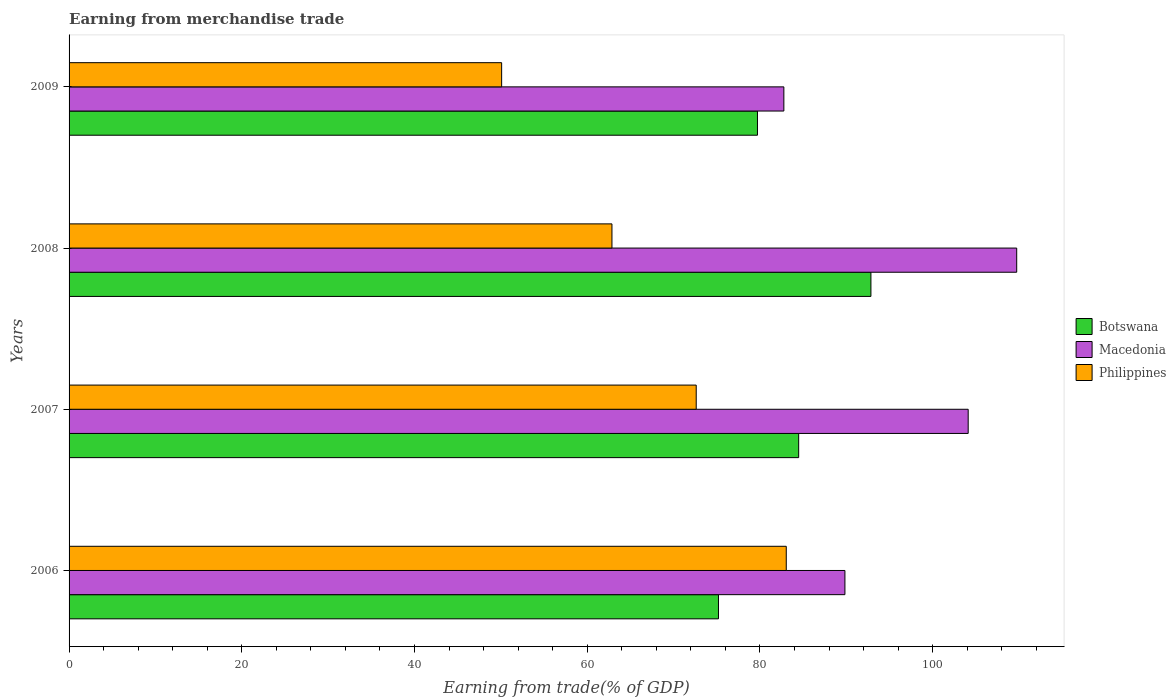How many different coloured bars are there?
Offer a very short reply. 3. How many groups of bars are there?
Give a very brief answer. 4. Are the number of bars per tick equal to the number of legend labels?
Provide a succinct answer. Yes. In how many cases, is the number of bars for a given year not equal to the number of legend labels?
Keep it short and to the point. 0. What is the earnings from trade in Philippines in 2006?
Ensure brevity in your answer.  83.04. Across all years, what is the maximum earnings from trade in Macedonia?
Offer a terse response. 109.73. Across all years, what is the minimum earnings from trade in Philippines?
Offer a very short reply. 50.09. In which year was the earnings from trade in Botswana minimum?
Give a very brief answer. 2006. What is the total earnings from trade in Botswana in the graph?
Provide a short and direct response. 332.23. What is the difference between the earnings from trade in Macedonia in 2006 and that in 2007?
Make the answer very short. -14.27. What is the difference between the earnings from trade in Botswana in 2006 and the earnings from trade in Philippines in 2009?
Your answer should be very brief. 25.11. What is the average earnings from trade in Philippines per year?
Provide a succinct answer. 67.15. In the year 2007, what is the difference between the earnings from trade in Botswana and earnings from trade in Macedonia?
Give a very brief answer. -19.63. In how many years, is the earnings from trade in Botswana greater than 68 %?
Make the answer very short. 4. What is the ratio of the earnings from trade in Botswana in 2007 to that in 2008?
Make the answer very short. 0.91. What is the difference between the highest and the second highest earnings from trade in Botswana?
Keep it short and to the point. 8.37. What is the difference between the highest and the lowest earnings from trade in Philippines?
Offer a very short reply. 32.96. In how many years, is the earnings from trade in Philippines greater than the average earnings from trade in Philippines taken over all years?
Keep it short and to the point. 2. What does the 3rd bar from the top in 2008 represents?
Provide a succinct answer. Botswana. What does the 2nd bar from the bottom in 2008 represents?
Give a very brief answer. Macedonia. How many bars are there?
Ensure brevity in your answer.  12. Are all the bars in the graph horizontal?
Offer a very short reply. Yes. Are the values on the major ticks of X-axis written in scientific E-notation?
Your answer should be compact. No. Where does the legend appear in the graph?
Ensure brevity in your answer.  Center right. What is the title of the graph?
Your response must be concise. Earning from merchandise trade. Does "Hungary" appear as one of the legend labels in the graph?
Your response must be concise. No. What is the label or title of the X-axis?
Give a very brief answer. Earning from trade(% of GDP). What is the Earning from trade(% of GDP) in Botswana in 2006?
Offer a terse response. 75.19. What is the Earning from trade(% of GDP) of Macedonia in 2006?
Give a very brief answer. 89.83. What is the Earning from trade(% of GDP) in Philippines in 2006?
Your answer should be compact. 83.04. What is the Earning from trade(% of GDP) in Botswana in 2007?
Offer a very short reply. 84.48. What is the Earning from trade(% of GDP) of Macedonia in 2007?
Give a very brief answer. 104.11. What is the Earning from trade(% of GDP) in Philippines in 2007?
Make the answer very short. 72.62. What is the Earning from trade(% of GDP) of Botswana in 2008?
Your answer should be very brief. 92.85. What is the Earning from trade(% of GDP) in Macedonia in 2008?
Offer a very short reply. 109.73. What is the Earning from trade(% of GDP) of Philippines in 2008?
Ensure brevity in your answer.  62.86. What is the Earning from trade(% of GDP) of Botswana in 2009?
Your answer should be very brief. 79.71. What is the Earning from trade(% of GDP) of Macedonia in 2009?
Give a very brief answer. 82.76. What is the Earning from trade(% of GDP) in Philippines in 2009?
Provide a succinct answer. 50.09. Across all years, what is the maximum Earning from trade(% of GDP) of Botswana?
Give a very brief answer. 92.85. Across all years, what is the maximum Earning from trade(% of GDP) of Macedonia?
Give a very brief answer. 109.73. Across all years, what is the maximum Earning from trade(% of GDP) of Philippines?
Offer a terse response. 83.04. Across all years, what is the minimum Earning from trade(% of GDP) in Botswana?
Offer a terse response. 75.19. Across all years, what is the minimum Earning from trade(% of GDP) of Macedonia?
Your answer should be very brief. 82.76. Across all years, what is the minimum Earning from trade(% of GDP) of Philippines?
Make the answer very short. 50.09. What is the total Earning from trade(% of GDP) in Botswana in the graph?
Offer a very short reply. 332.23. What is the total Earning from trade(% of GDP) of Macedonia in the graph?
Offer a terse response. 386.43. What is the total Earning from trade(% of GDP) of Philippines in the graph?
Give a very brief answer. 268.61. What is the difference between the Earning from trade(% of GDP) of Botswana in 2006 and that in 2007?
Your answer should be compact. -9.29. What is the difference between the Earning from trade(% of GDP) of Macedonia in 2006 and that in 2007?
Your response must be concise. -14.27. What is the difference between the Earning from trade(% of GDP) in Philippines in 2006 and that in 2007?
Ensure brevity in your answer.  10.43. What is the difference between the Earning from trade(% of GDP) of Botswana in 2006 and that in 2008?
Offer a very short reply. -17.65. What is the difference between the Earning from trade(% of GDP) in Macedonia in 2006 and that in 2008?
Ensure brevity in your answer.  -19.89. What is the difference between the Earning from trade(% of GDP) of Philippines in 2006 and that in 2008?
Make the answer very short. 20.18. What is the difference between the Earning from trade(% of GDP) of Botswana in 2006 and that in 2009?
Provide a short and direct response. -4.51. What is the difference between the Earning from trade(% of GDP) in Macedonia in 2006 and that in 2009?
Give a very brief answer. 7.07. What is the difference between the Earning from trade(% of GDP) in Philippines in 2006 and that in 2009?
Provide a short and direct response. 32.96. What is the difference between the Earning from trade(% of GDP) in Botswana in 2007 and that in 2008?
Provide a short and direct response. -8.37. What is the difference between the Earning from trade(% of GDP) in Macedonia in 2007 and that in 2008?
Keep it short and to the point. -5.62. What is the difference between the Earning from trade(% of GDP) of Philippines in 2007 and that in 2008?
Offer a terse response. 9.76. What is the difference between the Earning from trade(% of GDP) in Botswana in 2007 and that in 2009?
Your answer should be very brief. 4.77. What is the difference between the Earning from trade(% of GDP) in Macedonia in 2007 and that in 2009?
Your response must be concise. 21.34. What is the difference between the Earning from trade(% of GDP) of Philippines in 2007 and that in 2009?
Provide a short and direct response. 22.53. What is the difference between the Earning from trade(% of GDP) in Botswana in 2008 and that in 2009?
Your response must be concise. 13.14. What is the difference between the Earning from trade(% of GDP) in Macedonia in 2008 and that in 2009?
Your response must be concise. 26.96. What is the difference between the Earning from trade(% of GDP) in Philippines in 2008 and that in 2009?
Make the answer very short. 12.77. What is the difference between the Earning from trade(% of GDP) of Botswana in 2006 and the Earning from trade(% of GDP) of Macedonia in 2007?
Offer a terse response. -28.91. What is the difference between the Earning from trade(% of GDP) in Botswana in 2006 and the Earning from trade(% of GDP) in Philippines in 2007?
Make the answer very short. 2.58. What is the difference between the Earning from trade(% of GDP) of Macedonia in 2006 and the Earning from trade(% of GDP) of Philippines in 2007?
Your response must be concise. 17.22. What is the difference between the Earning from trade(% of GDP) in Botswana in 2006 and the Earning from trade(% of GDP) in Macedonia in 2008?
Provide a short and direct response. -34.53. What is the difference between the Earning from trade(% of GDP) of Botswana in 2006 and the Earning from trade(% of GDP) of Philippines in 2008?
Make the answer very short. 12.33. What is the difference between the Earning from trade(% of GDP) in Macedonia in 2006 and the Earning from trade(% of GDP) in Philippines in 2008?
Provide a succinct answer. 26.98. What is the difference between the Earning from trade(% of GDP) of Botswana in 2006 and the Earning from trade(% of GDP) of Macedonia in 2009?
Provide a short and direct response. -7.57. What is the difference between the Earning from trade(% of GDP) of Botswana in 2006 and the Earning from trade(% of GDP) of Philippines in 2009?
Provide a short and direct response. 25.11. What is the difference between the Earning from trade(% of GDP) of Macedonia in 2006 and the Earning from trade(% of GDP) of Philippines in 2009?
Give a very brief answer. 39.75. What is the difference between the Earning from trade(% of GDP) of Botswana in 2007 and the Earning from trade(% of GDP) of Macedonia in 2008?
Provide a succinct answer. -25.25. What is the difference between the Earning from trade(% of GDP) in Botswana in 2007 and the Earning from trade(% of GDP) in Philippines in 2008?
Provide a short and direct response. 21.62. What is the difference between the Earning from trade(% of GDP) in Macedonia in 2007 and the Earning from trade(% of GDP) in Philippines in 2008?
Your answer should be compact. 41.25. What is the difference between the Earning from trade(% of GDP) in Botswana in 2007 and the Earning from trade(% of GDP) in Macedonia in 2009?
Keep it short and to the point. 1.71. What is the difference between the Earning from trade(% of GDP) in Botswana in 2007 and the Earning from trade(% of GDP) in Philippines in 2009?
Ensure brevity in your answer.  34.39. What is the difference between the Earning from trade(% of GDP) of Macedonia in 2007 and the Earning from trade(% of GDP) of Philippines in 2009?
Ensure brevity in your answer.  54.02. What is the difference between the Earning from trade(% of GDP) of Botswana in 2008 and the Earning from trade(% of GDP) of Macedonia in 2009?
Keep it short and to the point. 10.08. What is the difference between the Earning from trade(% of GDP) of Botswana in 2008 and the Earning from trade(% of GDP) of Philippines in 2009?
Make the answer very short. 42.76. What is the difference between the Earning from trade(% of GDP) in Macedonia in 2008 and the Earning from trade(% of GDP) in Philippines in 2009?
Ensure brevity in your answer.  59.64. What is the average Earning from trade(% of GDP) in Botswana per year?
Your answer should be compact. 83.06. What is the average Earning from trade(% of GDP) of Macedonia per year?
Ensure brevity in your answer.  96.61. What is the average Earning from trade(% of GDP) of Philippines per year?
Keep it short and to the point. 67.15. In the year 2006, what is the difference between the Earning from trade(% of GDP) in Botswana and Earning from trade(% of GDP) in Macedonia?
Ensure brevity in your answer.  -14.64. In the year 2006, what is the difference between the Earning from trade(% of GDP) in Botswana and Earning from trade(% of GDP) in Philippines?
Your answer should be very brief. -7.85. In the year 2006, what is the difference between the Earning from trade(% of GDP) in Macedonia and Earning from trade(% of GDP) in Philippines?
Provide a short and direct response. 6.79. In the year 2007, what is the difference between the Earning from trade(% of GDP) in Botswana and Earning from trade(% of GDP) in Macedonia?
Your response must be concise. -19.63. In the year 2007, what is the difference between the Earning from trade(% of GDP) of Botswana and Earning from trade(% of GDP) of Philippines?
Your answer should be very brief. 11.86. In the year 2007, what is the difference between the Earning from trade(% of GDP) of Macedonia and Earning from trade(% of GDP) of Philippines?
Give a very brief answer. 31.49. In the year 2008, what is the difference between the Earning from trade(% of GDP) of Botswana and Earning from trade(% of GDP) of Macedonia?
Give a very brief answer. -16.88. In the year 2008, what is the difference between the Earning from trade(% of GDP) in Botswana and Earning from trade(% of GDP) in Philippines?
Your answer should be very brief. 29.99. In the year 2008, what is the difference between the Earning from trade(% of GDP) of Macedonia and Earning from trade(% of GDP) of Philippines?
Ensure brevity in your answer.  46.87. In the year 2009, what is the difference between the Earning from trade(% of GDP) in Botswana and Earning from trade(% of GDP) in Macedonia?
Ensure brevity in your answer.  -3.06. In the year 2009, what is the difference between the Earning from trade(% of GDP) in Botswana and Earning from trade(% of GDP) in Philippines?
Ensure brevity in your answer.  29.62. In the year 2009, what is the difference between the Earning from trade(% of GDP) in Macedonia and Earning from trade(% of GDP) in Philippines?
Provide a short and direct response. 32.68. What is the ratio of the Earning from trade(% of GDP) in Botswana in 2006 to that in 2007?
Offer a terse response. 0.89. What is the ratio of the Earning from trade(% of GDP) of Macedonia in 2006 to that in 2007?
Offer a terse response. 0.86. What is the ratio of the Earning from trade(% of GDP) of Philippines in 2006 to that in 2007?
Give a very brief answer. 1.14. What is the ratio of the Earning from trade(% of GDP) of Botswana in 2006 to that in 2008?
Your answer should be compact. 0.81. What is the ratio of the Earning from trade(% of GDP) in Macedonia in 2006 to that in 2008?
Provide a succinct answer. 0.82. What is the ratio of the Earning from trade(% of GDP) of Philippines in 2006 to that in 2008?
Provide a short and direct response. 1.32. What is the ratio of the Earning from trade(% of GDP) of Botswana in 2006 to that in 2009?
Provide a succinct answer. 0.94. What is the ratio of the Earning from trade(% of GDP) in Macedonia in 2006 to that in 2009?
Your response must be concise. 1.09. What is the ratio of the Earning from trade(% of GDP) of Philippines in 2006 to that in 2009?
Give a very brief answer. 1.66. What is the ratio of the Earning from trade(% of GDP) of Botswana in 2007 to that in 2008?
Make the answer very short. 0.91. What is the ratio of the Earning from trade(% of GDP) of Macedonia in 2007 to that in 2008?
Offer a very short reply. 0.95. What is the ratio of the Earning from trade(% of GDP) in Philippines in 2007 to that in 2008?
Your answer should be very brief. 1.16. What is the ratio of the Earning from trade(% of GDP) of Botswana in 2007 to that in 2009?
Your answer should be compact. 1.06. What is the ratio of the Earning from trade(% of GDP) of Macedonia in 2007 to that in 2009?
Provide a succinct answer. 1.26. What is the ratio of the Earning from trade(% of GDP) of Philippines in 2007 to that in 2009?
Ensure brevity in your answer.  1.45. What is the ratio of the Earning from trade(% of GDP) in Botswana in 2008 to that in 2009?
Give a very brief answer. 1.16. What is the ratio of the Earning from trade(% of GDP) in Macedonia in 2008 to that in 2009?
Provide a succinct answer. 1.33. What is the ratio of the Earning from trade(% of GDP) of Philippines in 2008 to that in 2009?
Provide a short and direct response. 1.25. What is the difference between the highest and the second highest Earning from trade(% of GDP) of Botswana?
Offer a terse response. 8.37. What is the difference between the highest and the second highest Earning from trade(% of GDP) of Macedonia?
Keep it short and to the point. 5.62. What is the difference between the highest and the second highest Earning from trade(% of GDP) in Philippines?
Keep it short and to the point. 10.43. What is the difference between the highest and the lowest Earning from trade(% of GDP) in Botswana?
Your response must be concise. 17.65. What is the difference between the highest and the lowest Earning from trade(% of GDP) in Macedonia?
Make the answer very short. 26.96. What is the difference between the highest and the lowest Earning from trade(% of GDP) of Philippines?
Provide a succinct answer. 32.96. 